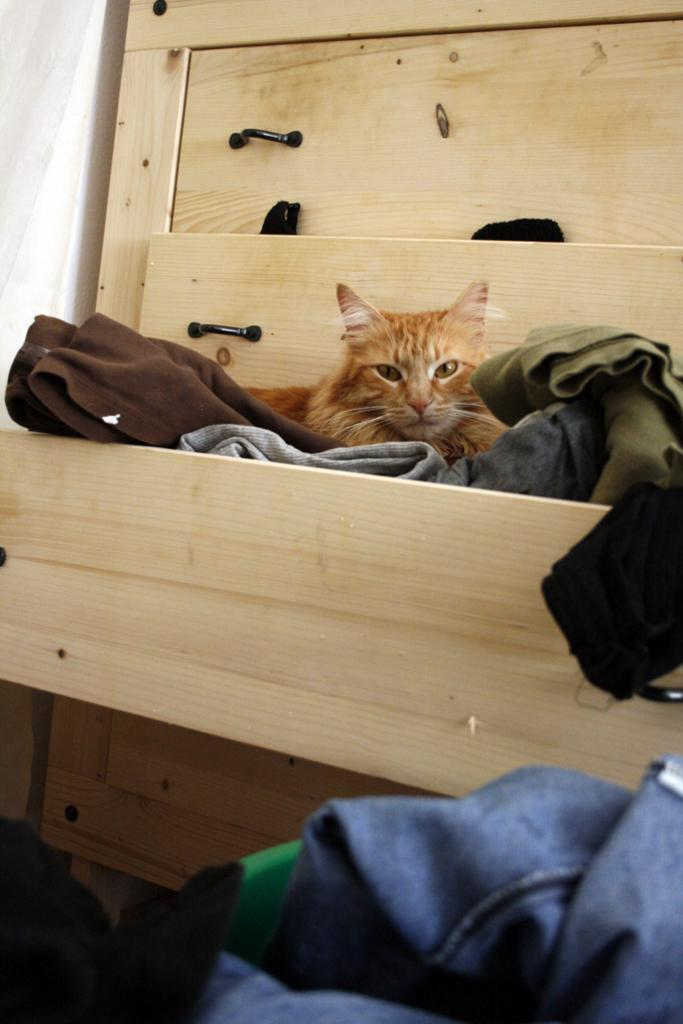What is the main subject in the center of the image? There is a cat in the center of the image. Where are the clothes stored in the image? The clothes are placed in a cupboard. What can be seen in the foreground of the image? There are clothes visible in the foreground. What is present in the background of the image? There is a curtain in the background. What type of furniture is being ordered in the image? There is no furniture being ordered in the image; it features a cat, clothes, a cupboard, and a curtain. 